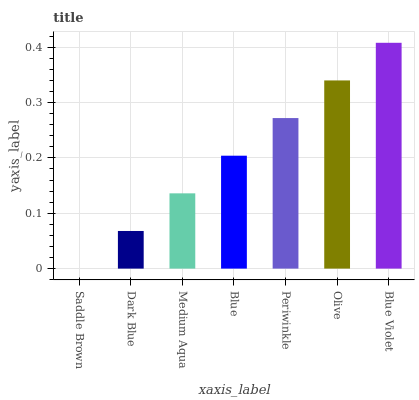Is Saddle Brown the minimum?
Answer yes or no. Yes. Is Blue Violet the maximum?
Answer yes or no. Yes. Is Dark Blue the minimum?
Answer yes or no. No. Is Dark Blue the maximum?
Answer yes or no. No. Is Dark Blue greater than Saddle Brown?
Answer yes or no. Yes. Is Saddle Brown less than Dark Blue?
Answer yes or no. Yes. Is Saddle Brown greater than Dark Blue?
Answer yes or no. No. Is Dark Blue less than Saddle Brown?
Answer yes or no. No. Is Blue the high median?
Answer yes or no. Yes. Is Blue the low median?
Answer yes or no. Yes. Is Medium Aqua the high median?
Answer yes or no. No. Is Periwinkle the low median?
Answer yes or no. No. 